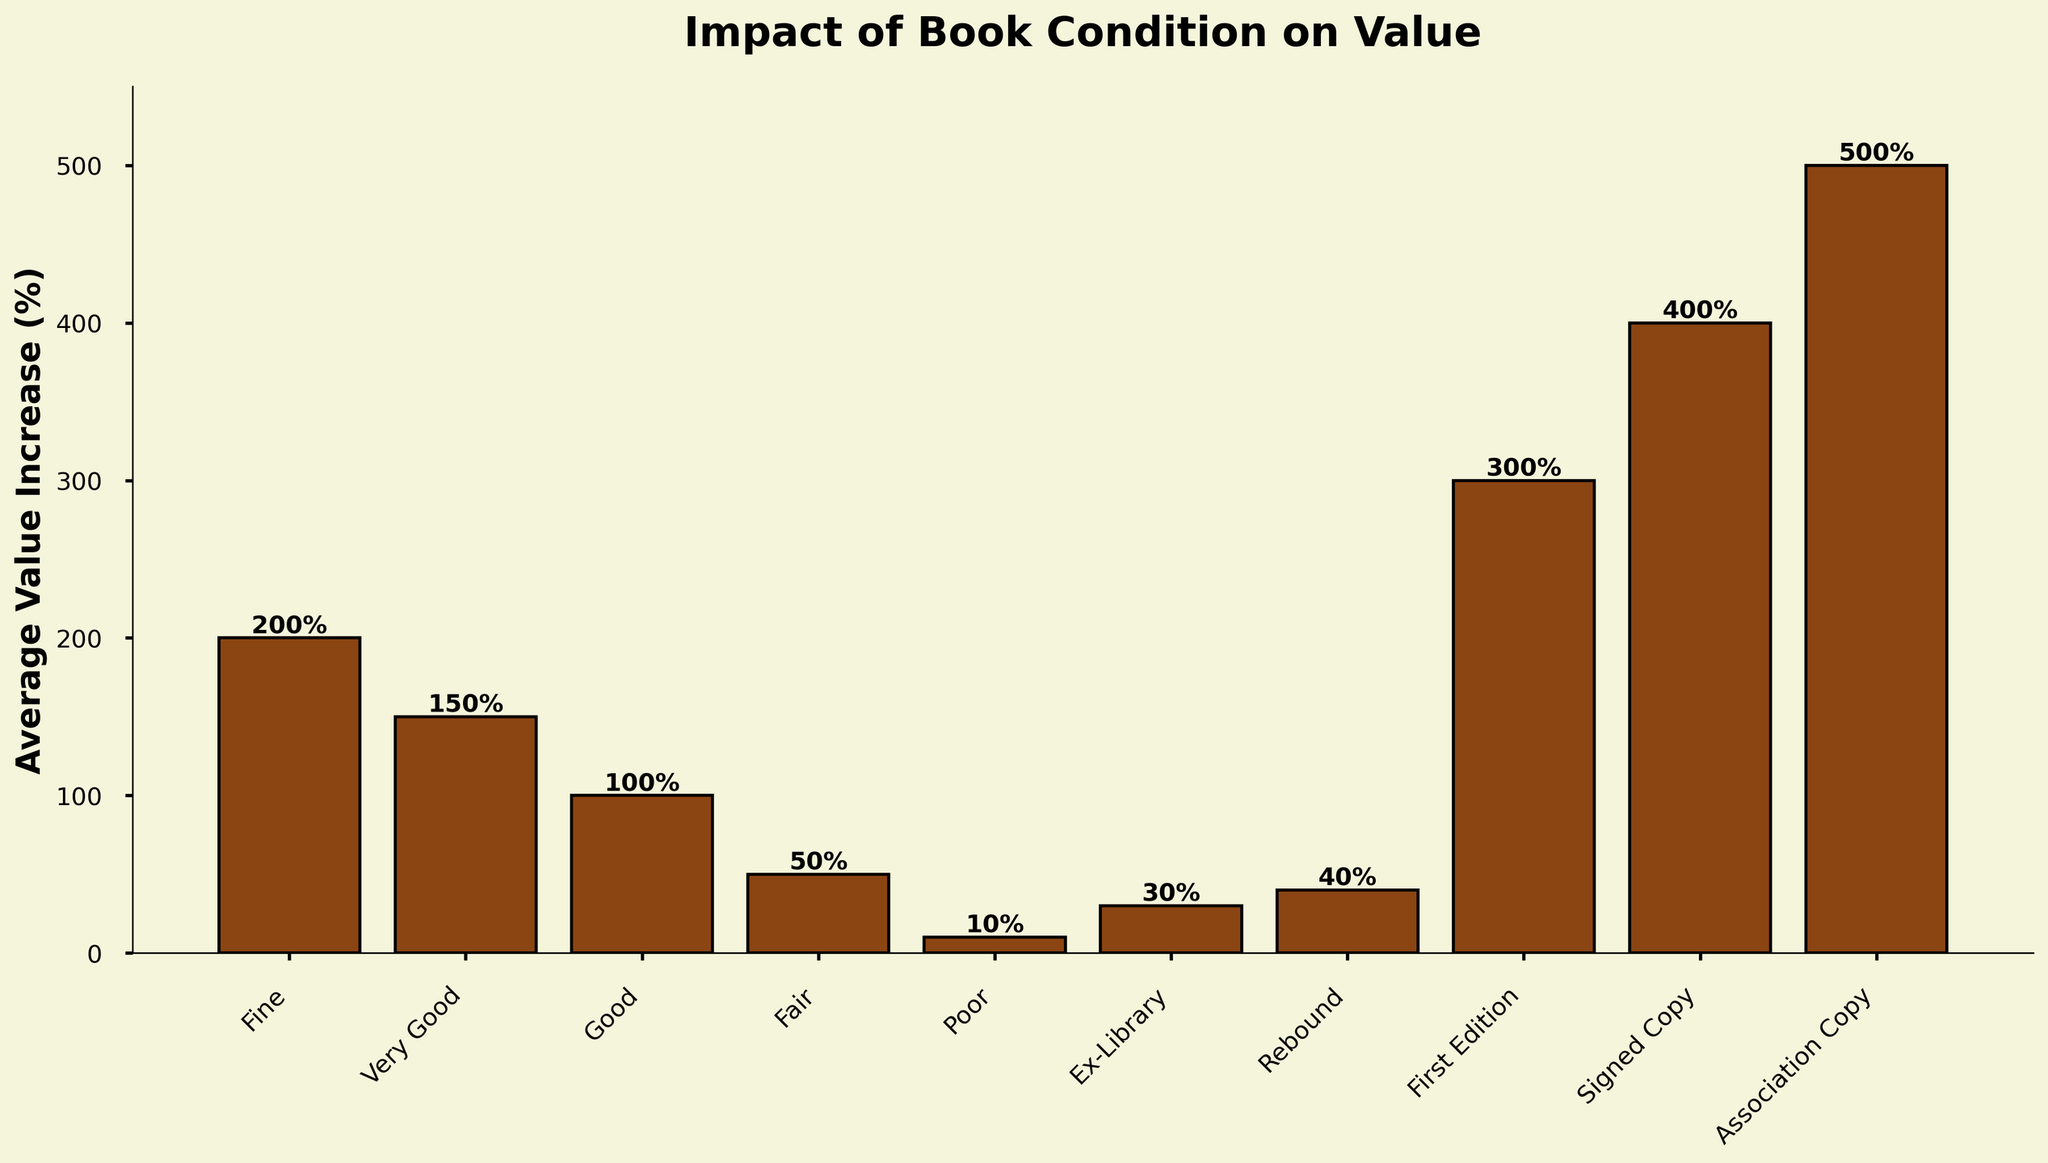Which book condition has the highest average value increase (%)? The highest bar represents the book condition with the highest average value increase. From the plot, the tallest bar corresponds to "Association Copy".
Answer: Association Copy Which two conditions have the lowest average value increase (%) and how do they compare? The two shortest bars represent the conditions with the lowest average value increase. These conditions are "Poor" and "Ex-Library". "Poor" has a 10% increase, while "Ex-Library" has a 30% increase, making "Poor" 20% lower than "Ex-Library".
Answer: Poor (10%) and Ex-Library (30%), with Poor being 20% lower What is the average value increase (%) for books in "Good" and "Very Good" conditions? Identify the bars representing "Good" and "Very Good". "Good" has 100% and "Very Good" has 150%. Average these values: (100 + 150) / 2 = 125%.
Answer: 125% Which book condition shows a greater value increase, "Fine" or "Rebound"? Compare the heights of the bars for "Fine" and "Rebound". "Fine" has a 200% increase, while "Rebound" has a 40% increase. Therefore, "Fine" shows a greater value increase.
Answer: Fine (200%) By how much does the value increase (%) for "Signed Copy" exceed that of "First Edition"? Identify the bars for "Signed Copy" and "First Edition". "Signed Copy" has a 400% increase and "First Edition" has a 300% increase. The difference is 400% - 300% = 100%.
Answer: 100% Which book condition has a value increase that is exactly half of "Fine"? Find the value increase for "Fine" which is 200%. Then look for the condition with a value increase of 100% (half of 200%). "Good" matches this criteria.
Answer: Good What is the combined value increase (%) for "Ex-Library" and "Rebound"? Identify the bars for "Ex-Library" and "Rebound". "Ex-Library" has a 30% increase and "Rebound" has a 40% increase. Sum these amounts: 30% + 40% = 70%.
Answer: 70% Which condition, "Fair" or "Good", is positioned to the right on the x-axis, and what are their respective average value increases (%)? Look at the x-axis for the positions of "Fair" and "Good". "Fair" is positioned to the left of "Good". The value increases are 50% for "Fair" and 100% for "Good".
Answer: Good is to the right, 50% (Fair), 100% (Good) Is there any condition with an average value increase higher than "First Edition" but lower than "Signed Copy"? If yes, name it. Identify the value increases for "First Edition" (300%) and "Signed Copy" (400%). Look for any bars with value increases between 300% and 400%. "Association Copy" fits this range with a 500% increase.
Answer: No, "Association Copy" has a higher increase than "Signed Copy" 